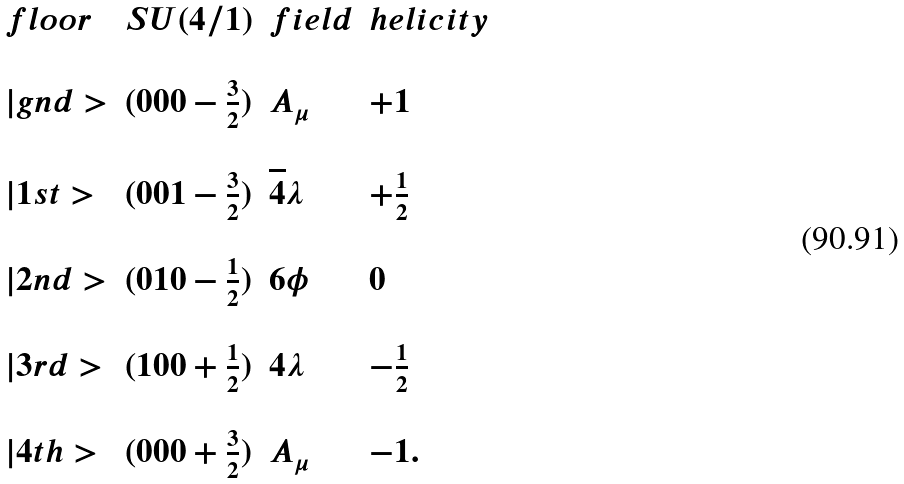<formula> <loc_0><loc_0><loc_500><loc_500>\begin{array} { l c l l } f l o o r & S U ( 4 / 1 ) & f i e l d & h e l i c i t y \\ \\ | g n d > & ( 0 0 0 - \frac { 3 } { 2 } ) & A _ { \mu } & + 1 \\ \\ | 1 s t > & ( 0 0 1 - \frac { 3 } { 2 } ) & \overline { 4 } \lambda & + \frac { 1 } { 2 } \\ \\ | 2 n d > & ( 0 1 0 - \frac { 1 } { 2 } ) & 6 \phi & 0 \\ \\ | 3 r d > & ( 1 0 0 + \frac { 1 } { 2 } ) & 4 \lambda & - \frac { 1 } { 2 } \\ \\ | 4 t h > & ( 0 0 0 + \frac { 3 } { 2 } ) & A _ { \mu } & - 1 . \\ \end{array}</formula> 